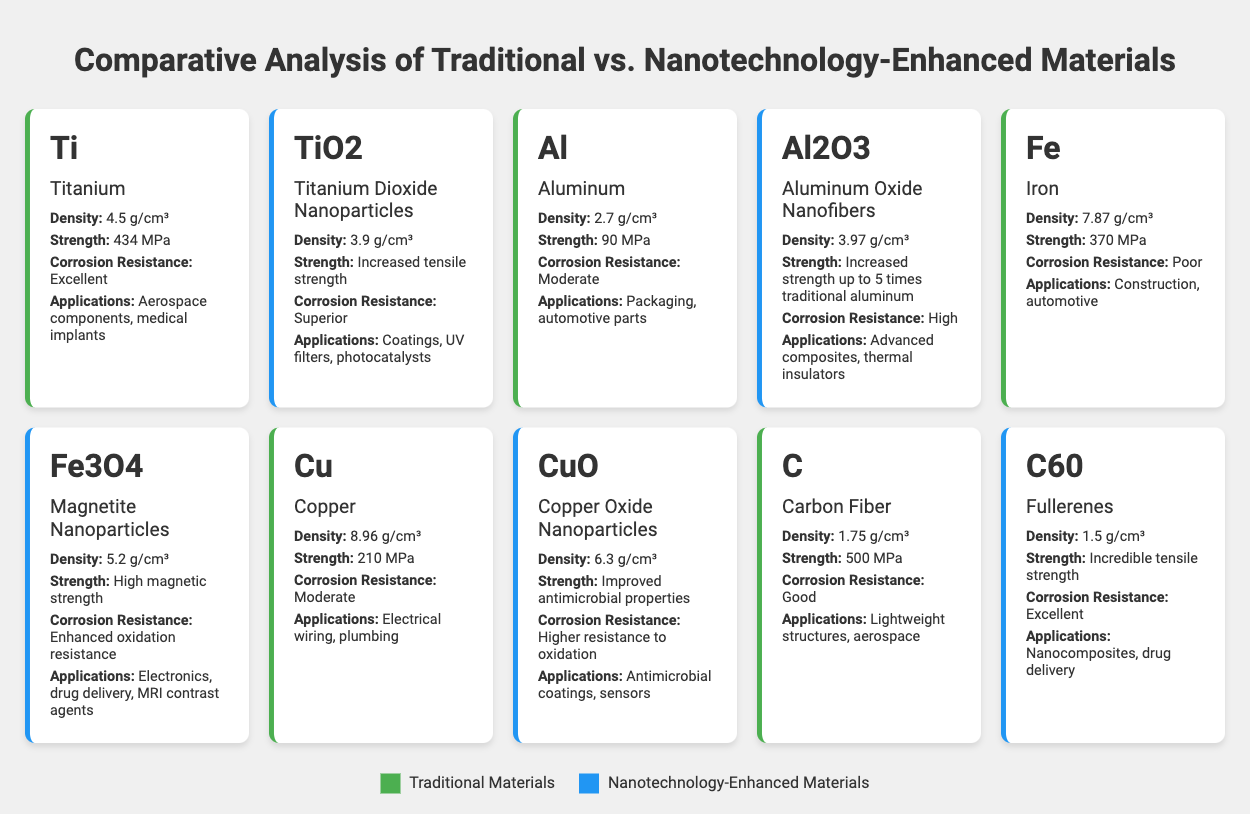What is the density of Titanium? The table lists the properties of Titanium under the Traditional category. It specifies that the density of Titanium is 4.5 g/cm³.
Answer: 4.5 g/cm³ Which material has a higher strength, Copper or Copper Oxide Nanoparticles? The table indicates that Copper has a strength of 210 MPa while Copper Oxide Nanoparticles have improved antimicrobial properties but no specific strength value is provided. Comparing the known strength values, Copper has a defined strength and there is no quantifiable strength value listed for the Copper Oxide Nanoparticles to conclude they are stronger.
Answer: Copper is stronger What applications are listed for Aluminum Oxide Nanofibers? The table shows that Aluminum Oxide Nanofibers are used in advanced composites and thermal insulators. This information is directly retrieved from the properties section of the Aluminum Oxide Nanofibers entry.
Answer: Advanced composites, thermal insulators Is Titanium Dioxide Nanoparticles considered a traditional material? The table categorizes materials as either Traditional or Nanotechnology-enhanced. Titanium Dioxide Nanoparticles are marked as Nanotechnology-enhanced, which means it is not a traditional material.
Answer: No What is the difference in density between Iron and Magnetite Nanoparticles? The density of Iron is listed as 7.87 g/cm³ and the density of Magnetite Nanoparticles is 5.2 g/cm³. The difference can be calculated by subtracting the density of Magnetite from that of Iron: 7.87 g/cm³ - 5.2 g/cm³ = 2.67 g/cm³.
Answer: 2.67 g/cm³ What is the combined strength of Titanium and Aluminum? The strength of Titanium is 434 MPa and the strength of Aluminum is 90 MPa. To find the combined strength, we add these values together: 434 MPa + 90 MPa = 524 MPa.
Answer: 524 MPa Which nanotechnology-enhanced material has better corrosion resistance, Titanium Dioxide Nanoparticles or Aluminum Oxide Nanofibers? The properties show that Titanium Dioxide Nanoparticles have superior corrosion resistance, whereas Aluminum Oxide Nanofibers have high corrosion resistance. Superior is greater than high, making Titanium Dioxide Nanoparticles the material with better corrosion resistance.
Answer: Titanium Dioxide Nanoparticles In terms of strength, which has the highest value among the traditional materials listed? The table indicates the strengths of the traditional materials: Titanium (434 MPa), Aluminum (90 MPa), Iron (370 MPa), and Copper (210 MPa). Comparing these values, Titanium has the highest strength at 434 MPa.
Answer: Titanium What applications are common between the Copper and Copper Oxide Nanoparticles? The table lists the applications of Copper as electrical wiring and plumbing, whereas Copper Oxide Nanoparticles are used in antimicrobial coatings and sensors. As there are no overlapping applications mentioned for both, they do not share common applications.
Answer: No common applications 